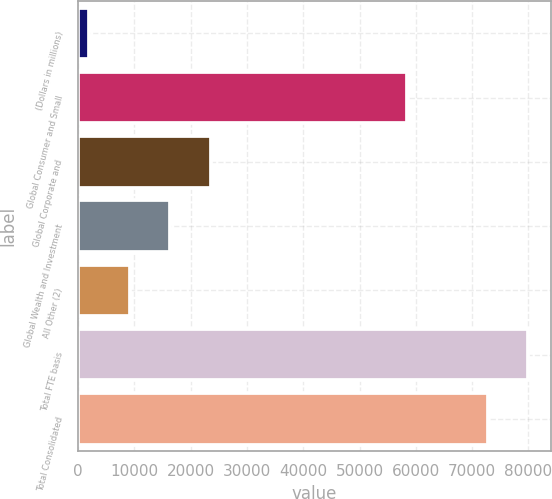<chart> <loc_0><loc_0><loc_500><loc_500><bar_chart><fcel>(Dollars in millions)<fcel>Global Consumer and Small<fcel>Global Corporate and<fcel>Global Wealth and Investment<fcel>All Other (2)<fcel>Total FTE basis<fcel>Total Consolidated<nl><fcel>2008<fcel>58344<fcel>23598.4<fcel>16401.6<fcel>9204.8<fcel>79978.8<fcel>72782<nl></chart> 